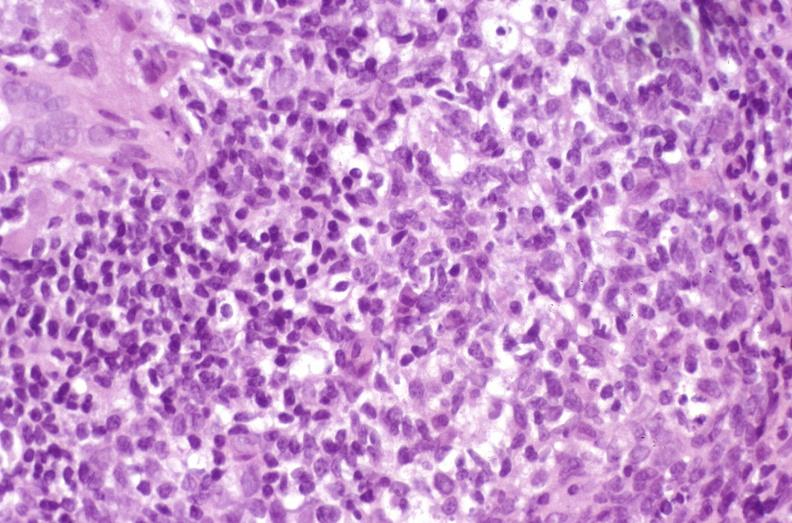s liver present?
Answer the question using a single word or phrase. Yes 